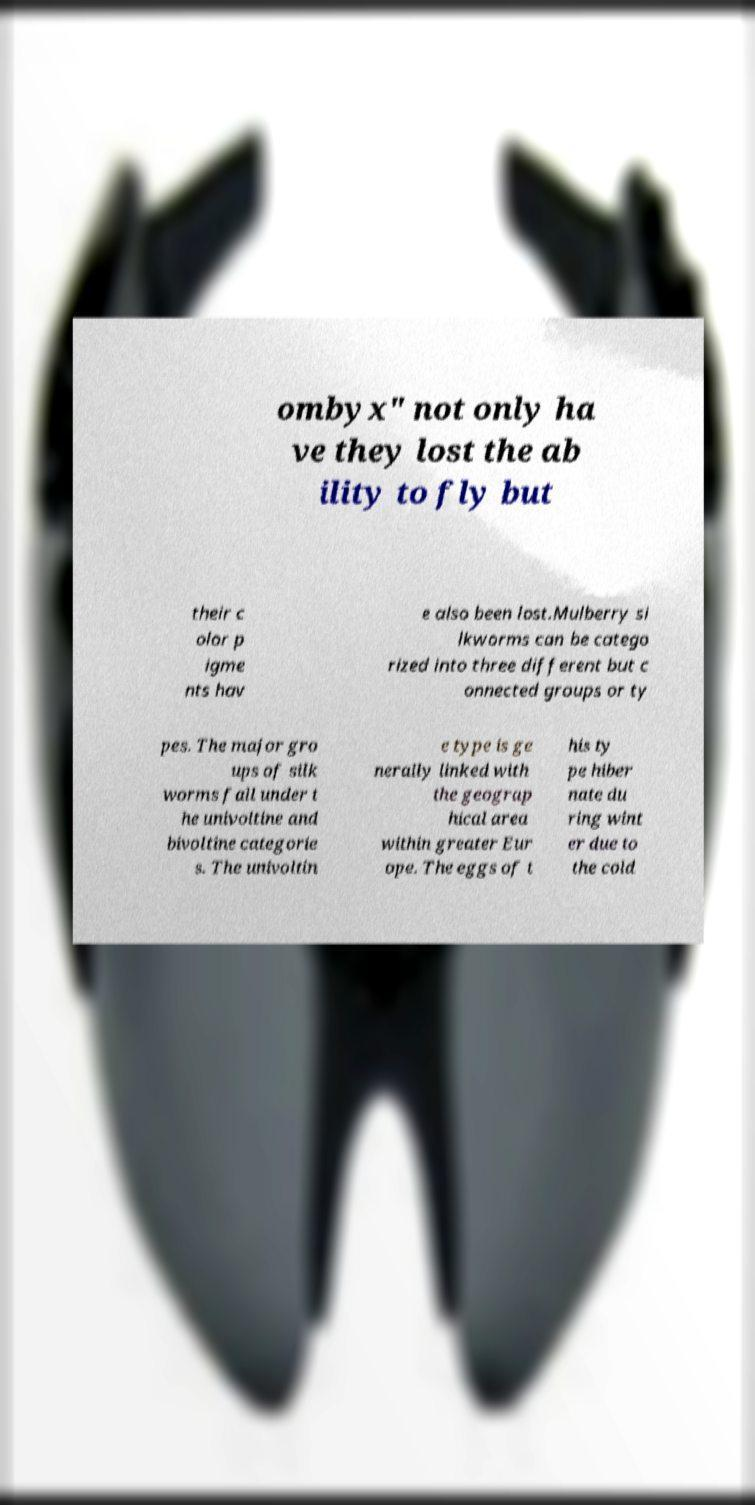Can you read and provide the text displayed in the image?This photo seems to have some interesting text. Can you extract and type it out for me? ombyx" not only ha ve they lost the ab ility to fly but their c olor p igme nts hav e also been lost.Mulberry si lkworms can be catego rized into three different but c onnected groups or ty pes. The major gro ups of silk worms fall under t he univoltine and bivoltine categorie s. The univoltin e type is ge nerally linked with the geograp hical area within greater Eur ope. The eggs of t his ty pe hiber nate du ring wint er due to the cold 